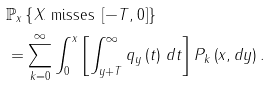Convert formula to latex. <formula><loc_0><loc_0><loc_500><loc_500>& \mathbb { P } _ { x } \left \{ X _ { \cdot \text { } } \text {misses } \left [ - T , 0 \right ] \right \} \\ & = \sum _ { k = 0 } ^ { \infty } \int _ { 0 } ^ { x } \left [ \int _ { y + T } ^ { \infty } q _ { y } \left ( t \right ) \, d t \right ] P _ { k } \left ( x , d y \right ) .</formula> 